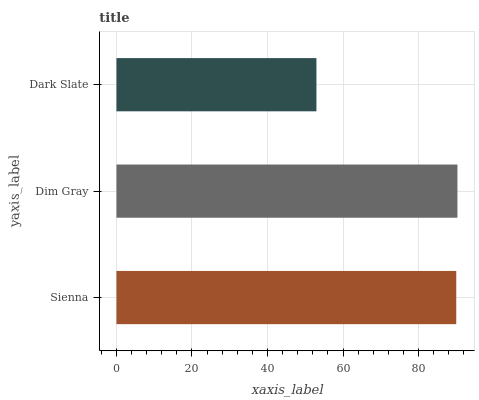Is Dark Slate the minimum?
Answer yes or no. Yes. Is Dim Gray the maximum?
Answer yes or no. Yes. Is Dim Gray the minimum?
Answer yes or no. No. Is Dark Slate the maximum?
Answer yes or no. No. Is Dim Gray greater than Dark Slate?
Answer yes or no. Yes. Is Dark Slate less than Dim Gray?
Answer yes or no. Yes. Is Dark Slate greater than Dim Gray?
Answer yes or no. No. Is Dim Gray less than Dark Slate?
Answer yes or no. No. Is Sienna the high median?
Answer yes or no. Yes. Is Sienna the low median?
Answer yes or no. Yes. Is Dark Slate the high median?
Answer yes or no. No. Is Dark Slate the low median?
Answer yes or no. No. 